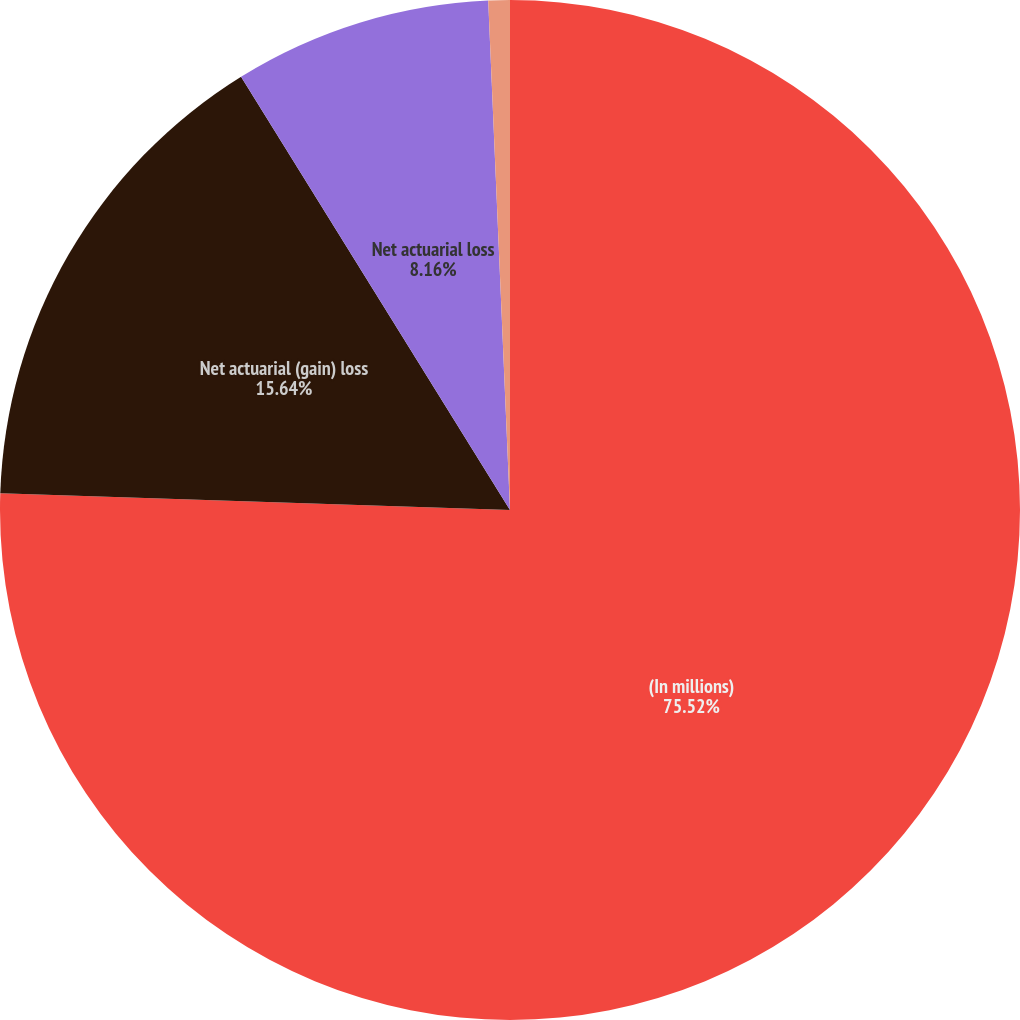Convert chart to OTSL. <chart><loc_0><loc_0><loc_500><loc_500><pie_chart><fcel>(In millions)<fcel>Net actuarial (gain) loss<fcel>Net actuarial loss<fcel>Total recognized in other<nl><fcel>75.52%<fcel>15.64%<fcel>8.16%<fcel>0.68%<nl></chart> 